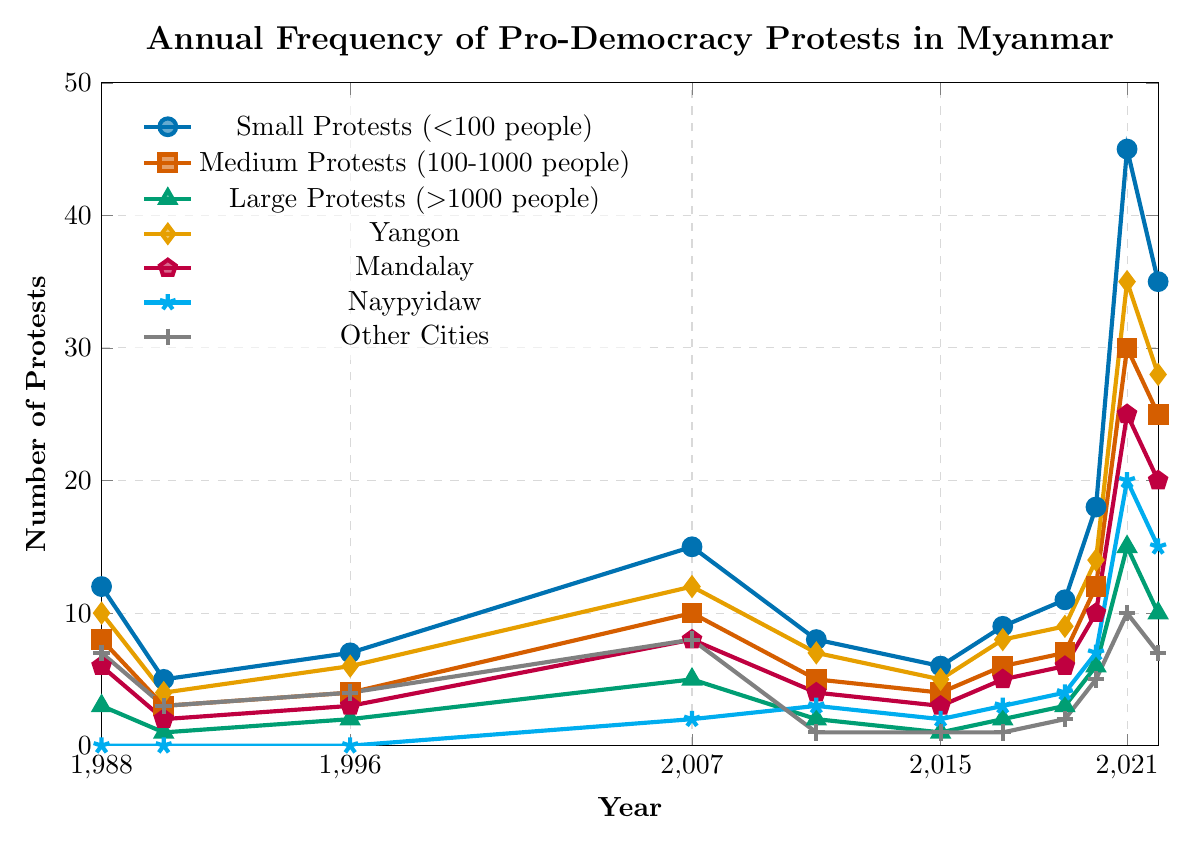What's the total number of protests in 2021 across all categories? To find the total number of protests in 2021, we sum the values for all categories for the year 2021: (45 small + 30 medium + 15 large + 35 Yangon + 25 Mandalay + 20 Naypyidaw + 10 other cities). Therefore, the total is 45 + 30 + 15 + 35 + 25 + 20 + 10 = 180.
Answer: 180 Which year experienced the highest number of small protests? Look for the year with the highest value in the "Small Protests" category. The peak value is in 2021 with 45 small protests.
Answer: 2021 How many large protests occurred in Yangon in 2007? Since the protests are categorized and provided separately for size and location in the dataset, directly referencing the figure for the combined data is necessary. For large protests in Yangon specifically, the figure shows 5 large protests in 2007.
Answer: 5 What is the difference in the number of protests between 1988 and 2022 for medium-sized protests? Subtract the number of medium protests in 1988 from those in 2022. So, it's 25 (2022) - 8 (1988) = 17.
Answer: 17 Which city had the least number of protests in 2011? Checking the values for each city in 2011, Naypyidaw had the least with 3 protests.
Answer: Naypyidaw How does the number of protests in Mandalay in 2021 compare to those in 2022? Compare the values for Mandalay in 2021 and 2022: Mandalay had 25 protests in 2021 and 20 in 2022. Therefore, 2021 had more protests.
Answer: 2021 What was the average number of large protests in the years 1996, 2007, and 2017 combined? Calculate the average by summing the values of large protests for 1996 (2), 2007 (5), and 2017 (2), then divide by 3. The sum is 2 + 5 + 2 = 9, and the average is 9 / 3 = 3.
Answer: 3 How many more protests were there in 2021 compared to 2020 for small and medium-sized combined? Calculate the total number of protests for small and medium categories in 2020 and 2021, then subtract. Combining small and medium for 2020: 18 (small) + 12 (medium) = 30. Combining for 2021: 45 (small) + 30 (medium) = 75. The difference is 75 - 30 = 45.
Answer: 45 